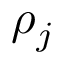Convert formula to latex. <formula><loc_0><loc_0><loc_500><loc_500>\rho _ { j }</formula> 